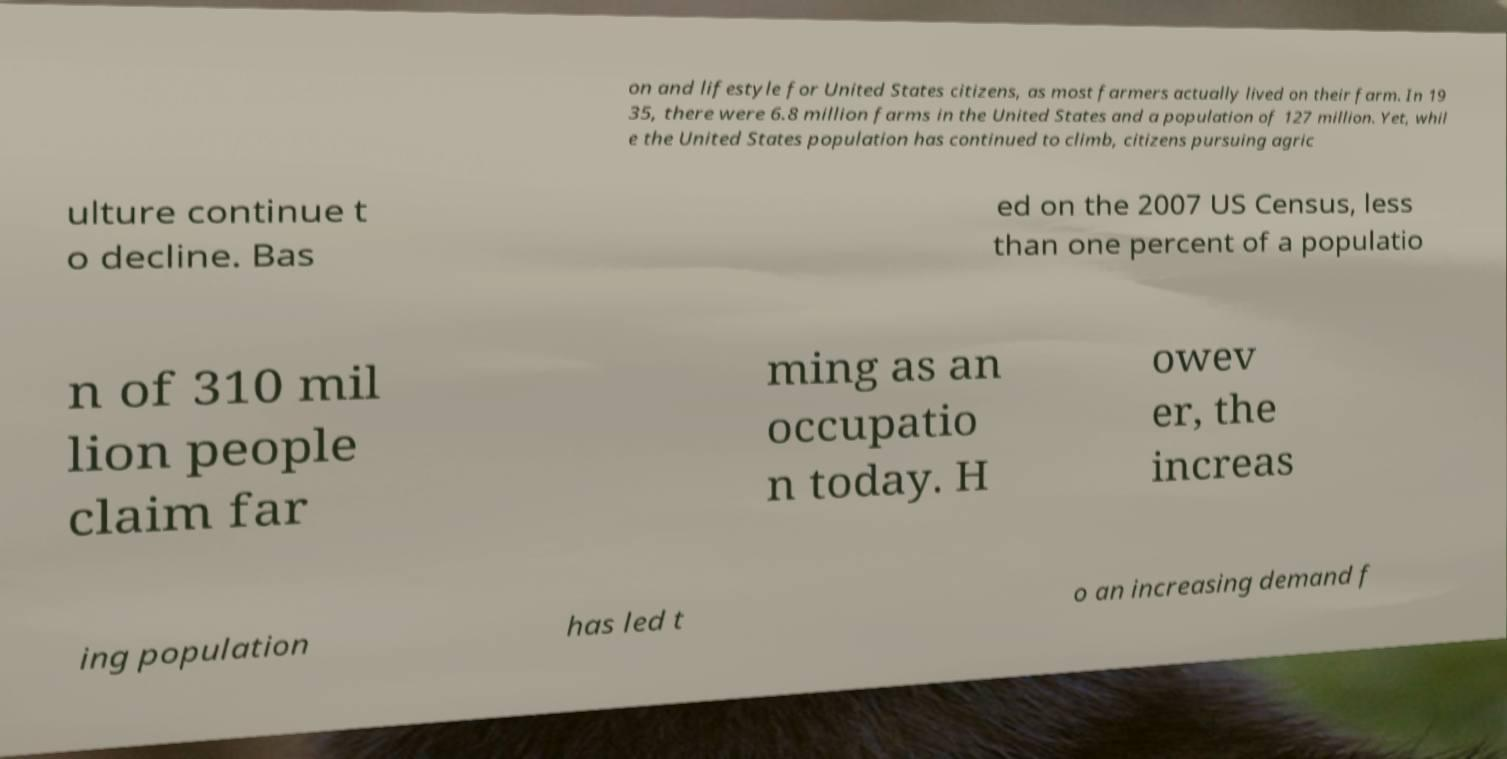Please identify and transcribe the text found in this image. on and lifestyle for United States citizens, as most farmers actually lived on their farm. In 19 35, there were 6.8 million farms in the United States and a population of 127 million. Yet, whil e the United States population has continued to climb, citizens pursuing agric ulture continue t o decline. Bas ed on the 2007 US Census, less than one percent of a populatio n of 310 mil lion people claim far ming as an occupatio n today. H owev er, the increas ing population has led t o an increasing demand f 